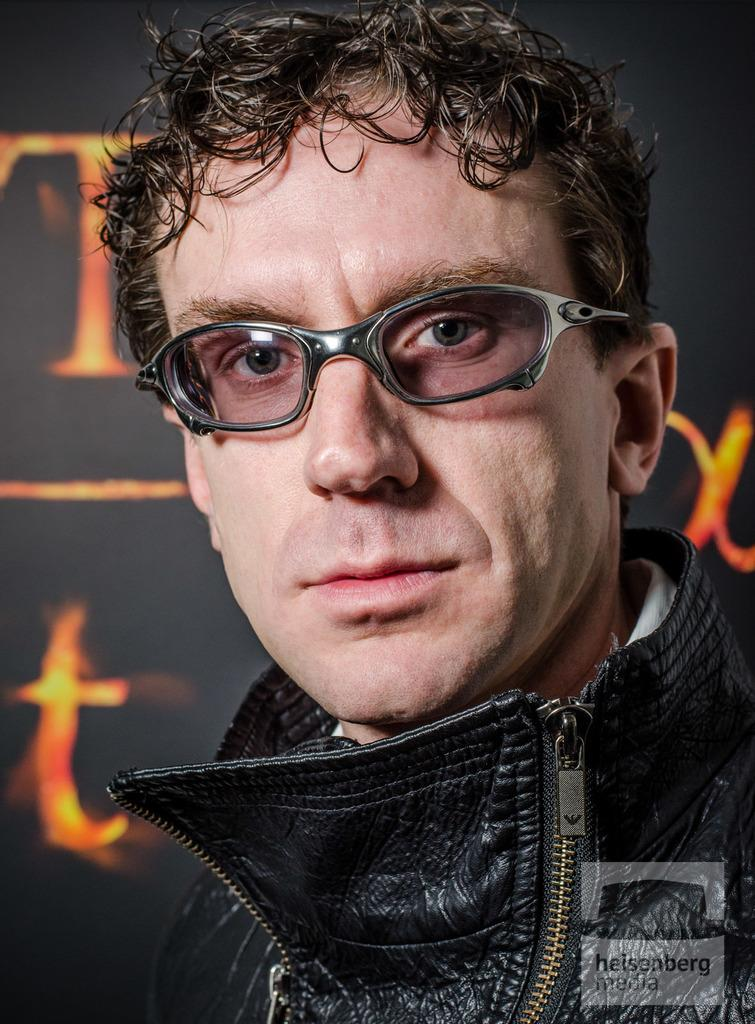What is the main subject of the image? The main subject of the image is a man. Can you describe the man's appearance in the image? The man is wearing spectacles in the image. What type of current is flowing through the copper wire in the image? There is no copper wire or current present in the image; it only features a man wearing spectacles. 